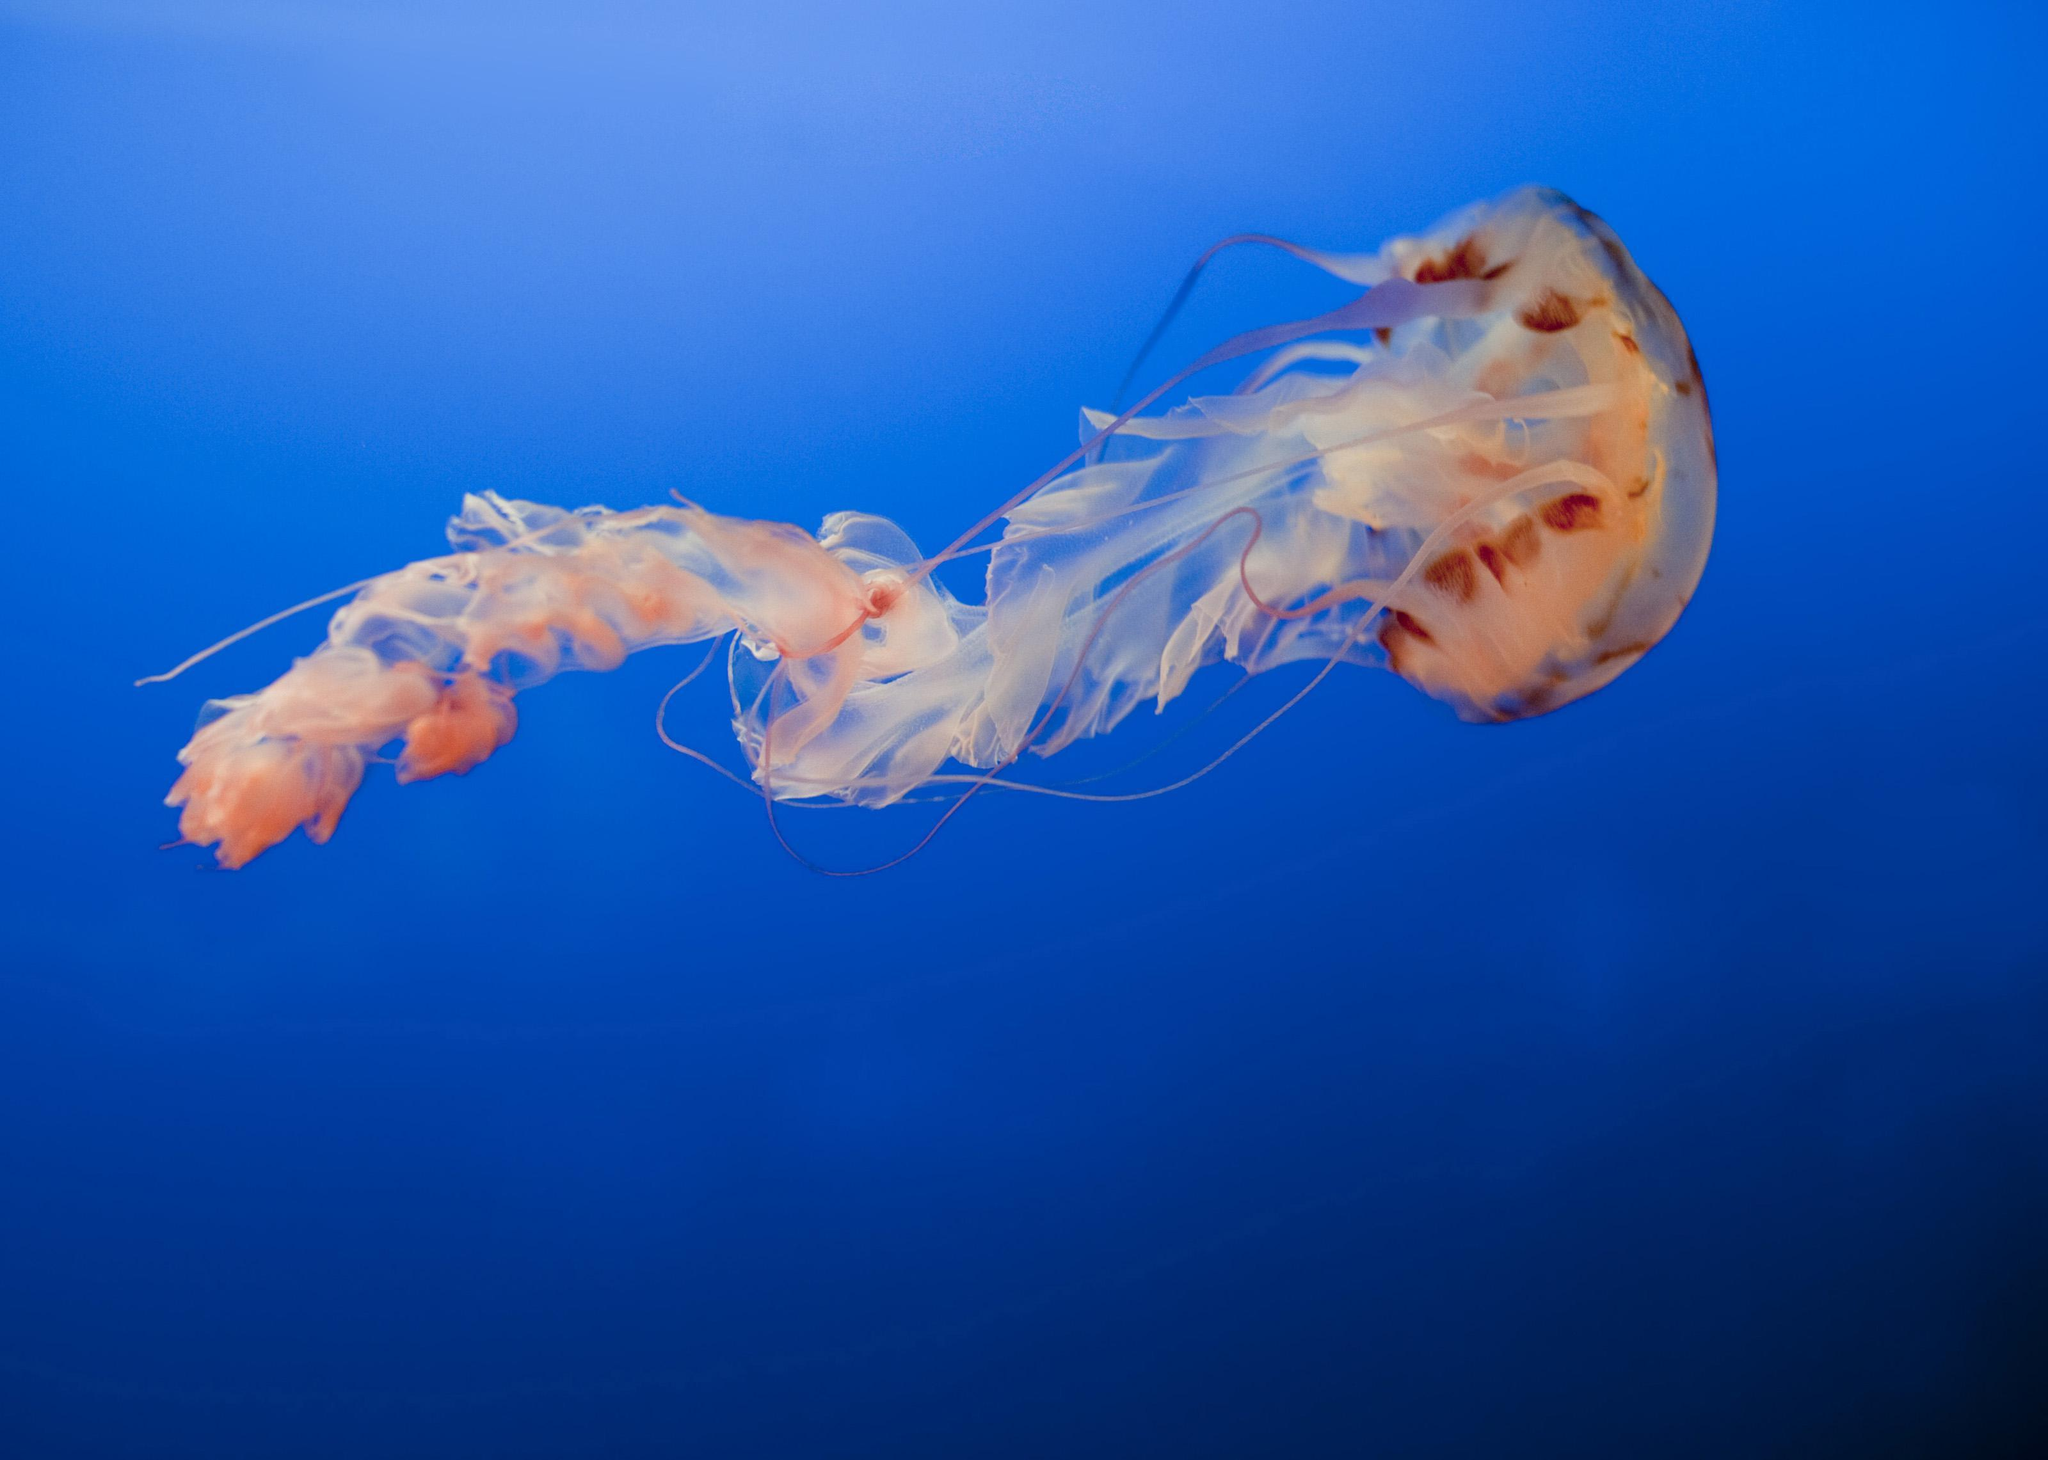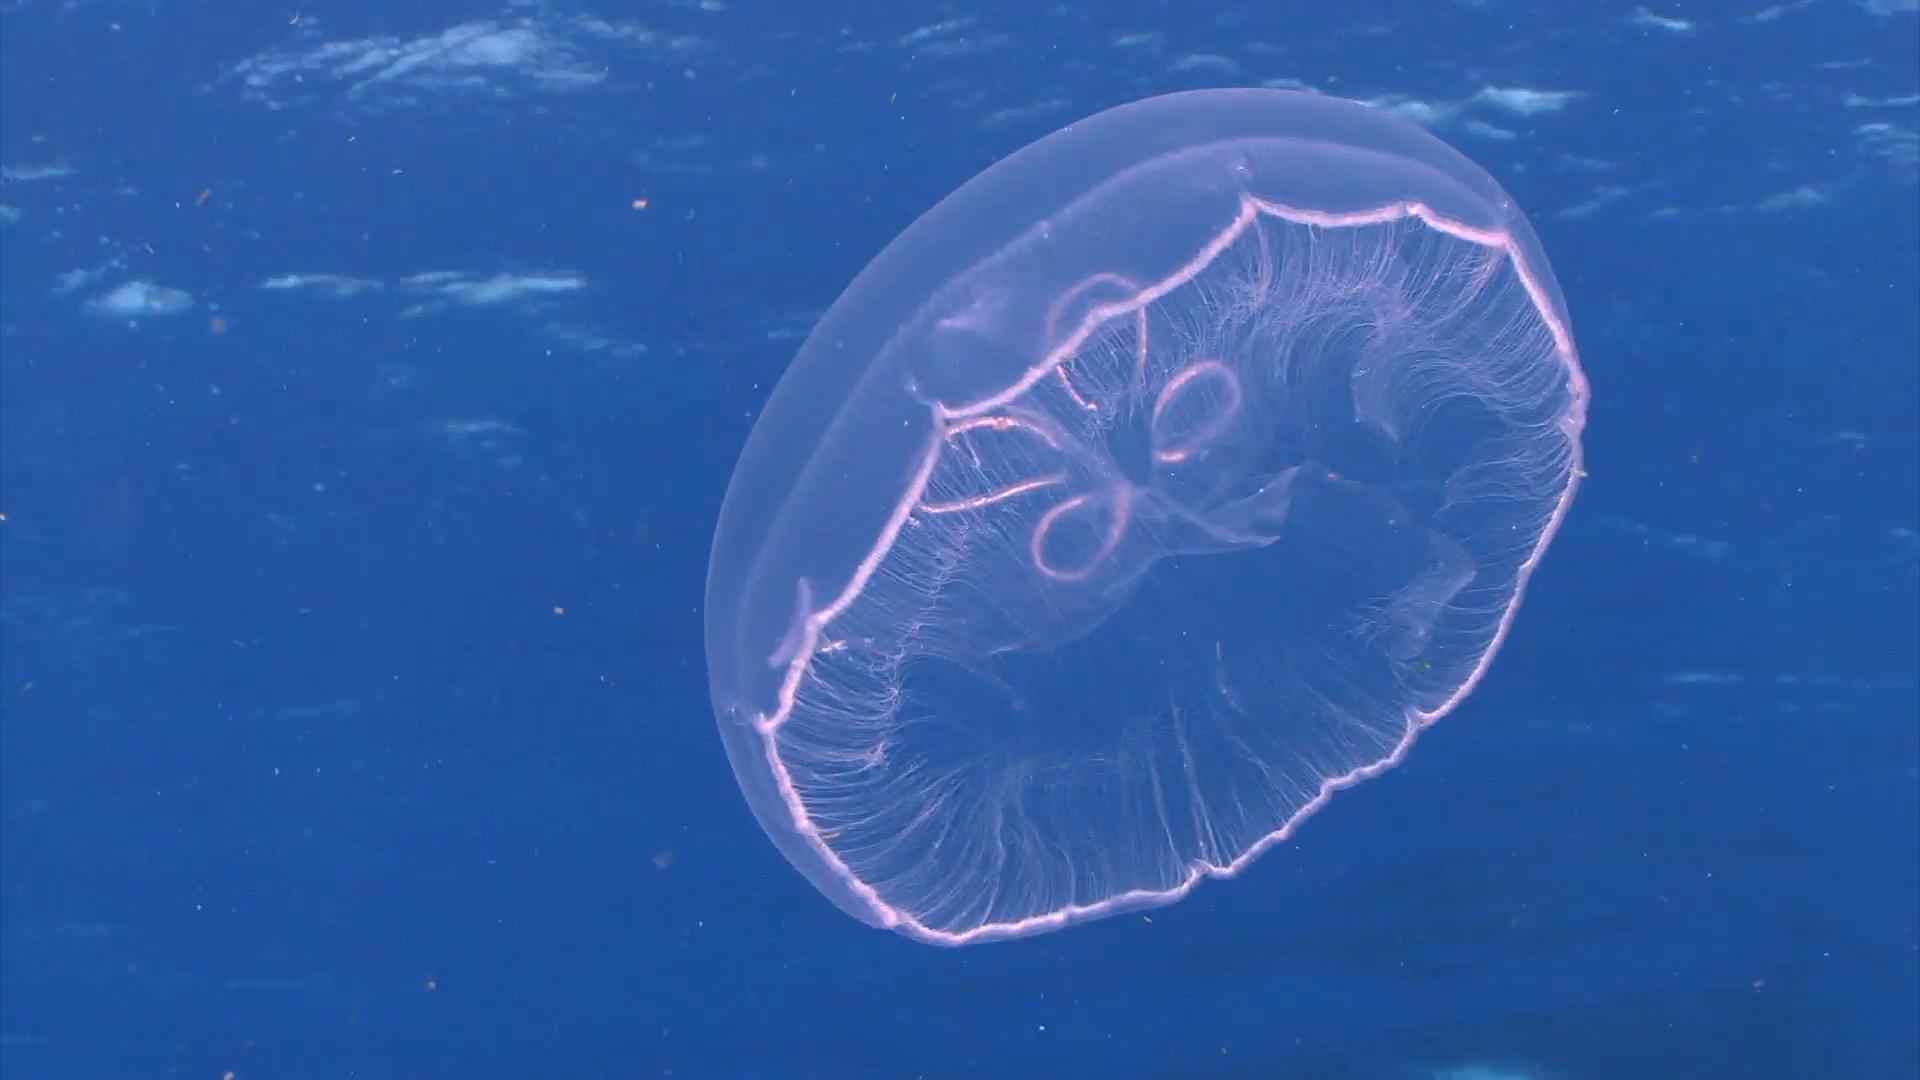The first image is the image on the left, the second image is the image on the right. Analyze the images presented: Is the assertion "Several jellyfish are swimming in the water in the image on the left." valid? Answer yes or no. No. 